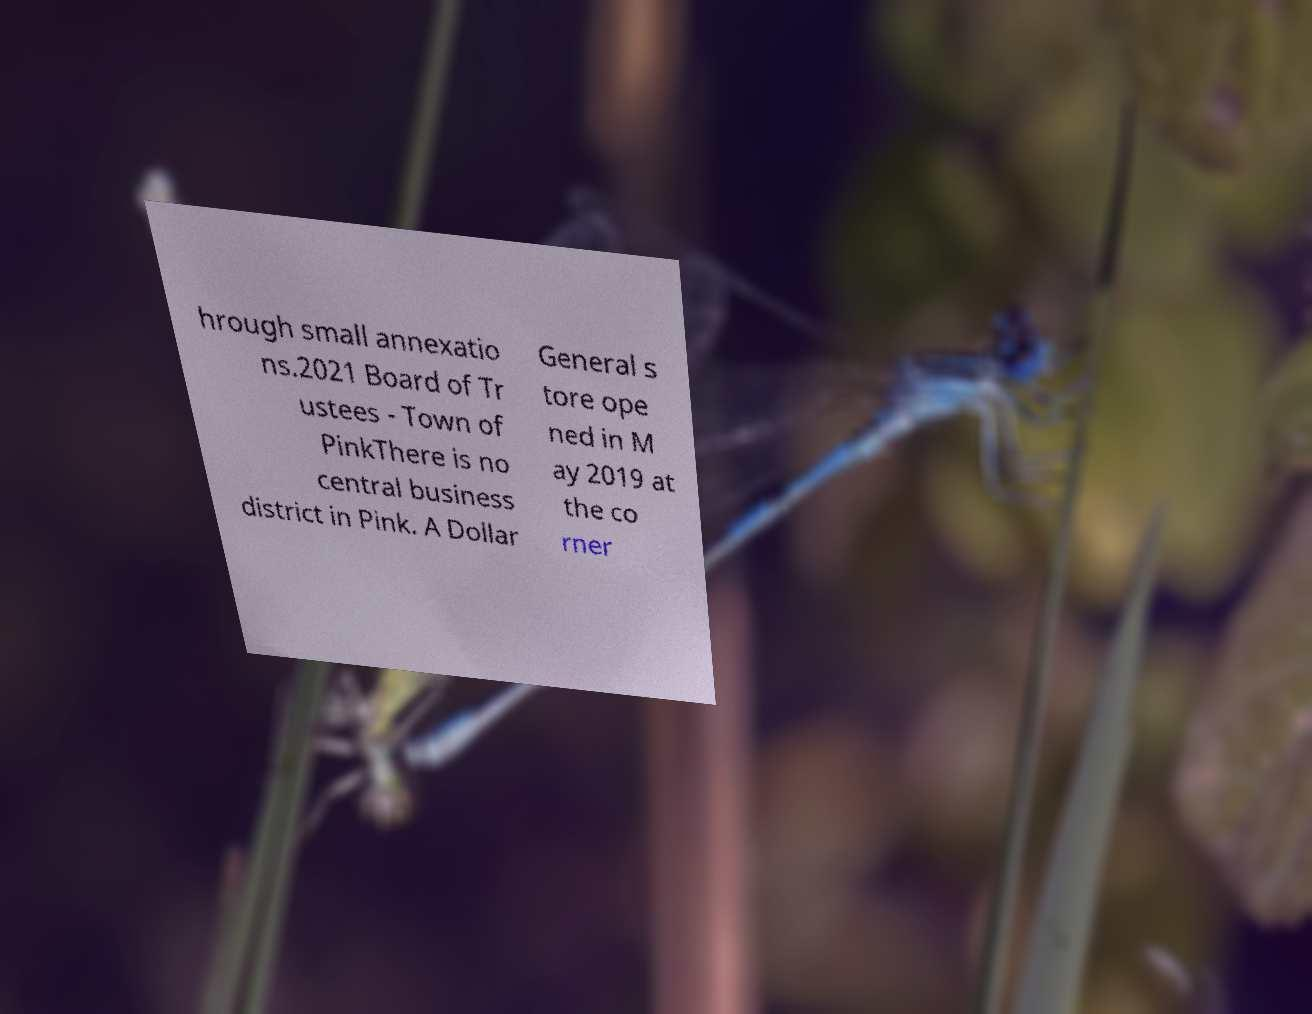There's text embedded in this image that I need extracted. Can you transcribe it verbatim? hrough small annexatio ns.2021 Board of Tr ustees - Town of PinkThere is no central business district in Pink. A Dollar General s tore ope ned in M ay 2019 at the co rner 